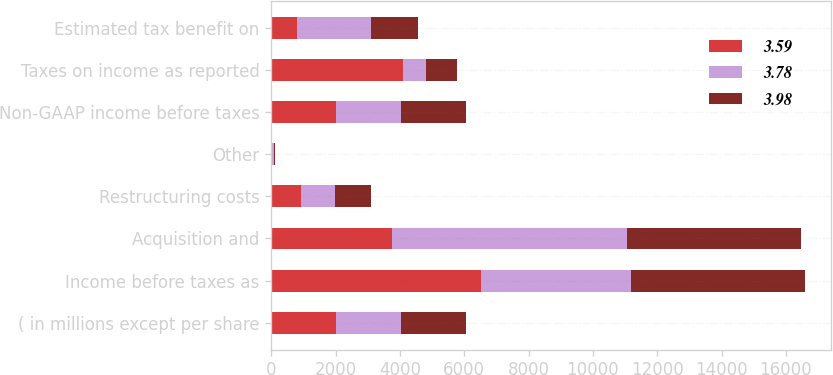<chart> <loc_0><loc_0><loc_500><loc_500><stacked_bar_chart><ecel><fcel>( in millions except per share<fcel>Income before taxes as<fcel>Acquisition and<fcel>Restructuring costs<fcel>Other<fcel>Non-GAAP income before taxes<fcel>Taxes on income as reported<fcel>Estimated tax benefit on<nl><fcel>3.59<fcel>2017<fcel>6521<fcel>3760<fcel>927<fcel>16<fcel>2015<fcel>4103<fcel>785<nl><fcel>3.78<fcel>2016<fcel>4659<fcel>7312<fcel>1069<fcel>67<fcel>2015<fcel>718<fcel>2321<nl><fcel>3.98<fcel>2015<fcel>5401<fcel>5398<fcel>1110<fcel>34<fcel>2015<fcel>942<fcel>1470<nl></chart> 